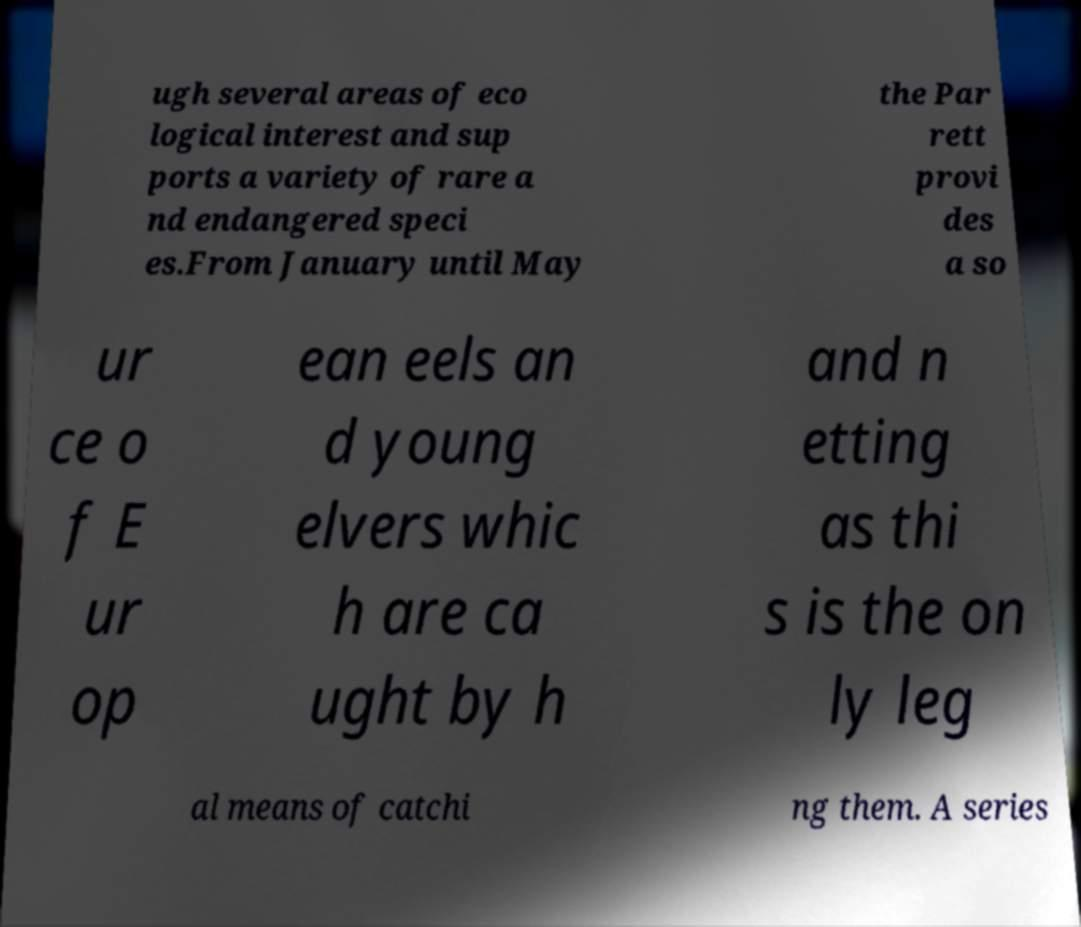Please identify and transcribe the text found in this image. ugh several areas of eco logical interest and sup ports a variety of rare a nd endangered speci es.From January until May the Par rett provi des a so ur ce o f E ur op ean eels an d young elvers whic h are ca ught by h and n etting as thi s is the on ly leg al means of catchi ng them. A series 